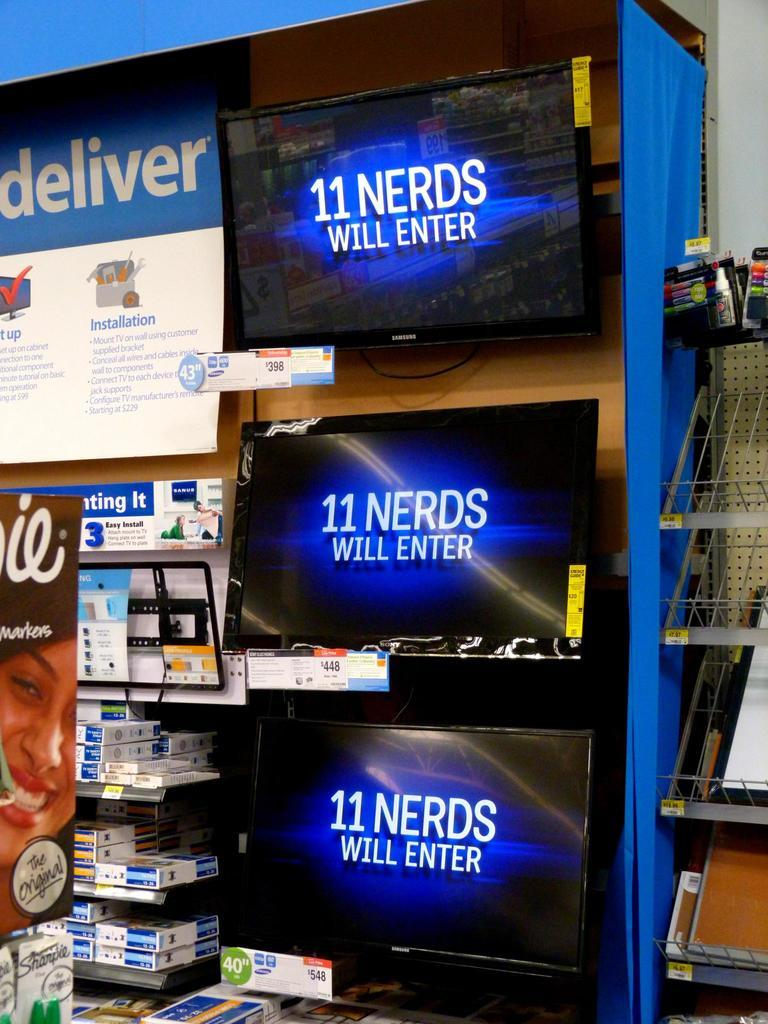<image>
Give a short and clear explanation of the subsequent image. an 11 nerds will enter sign on a car 